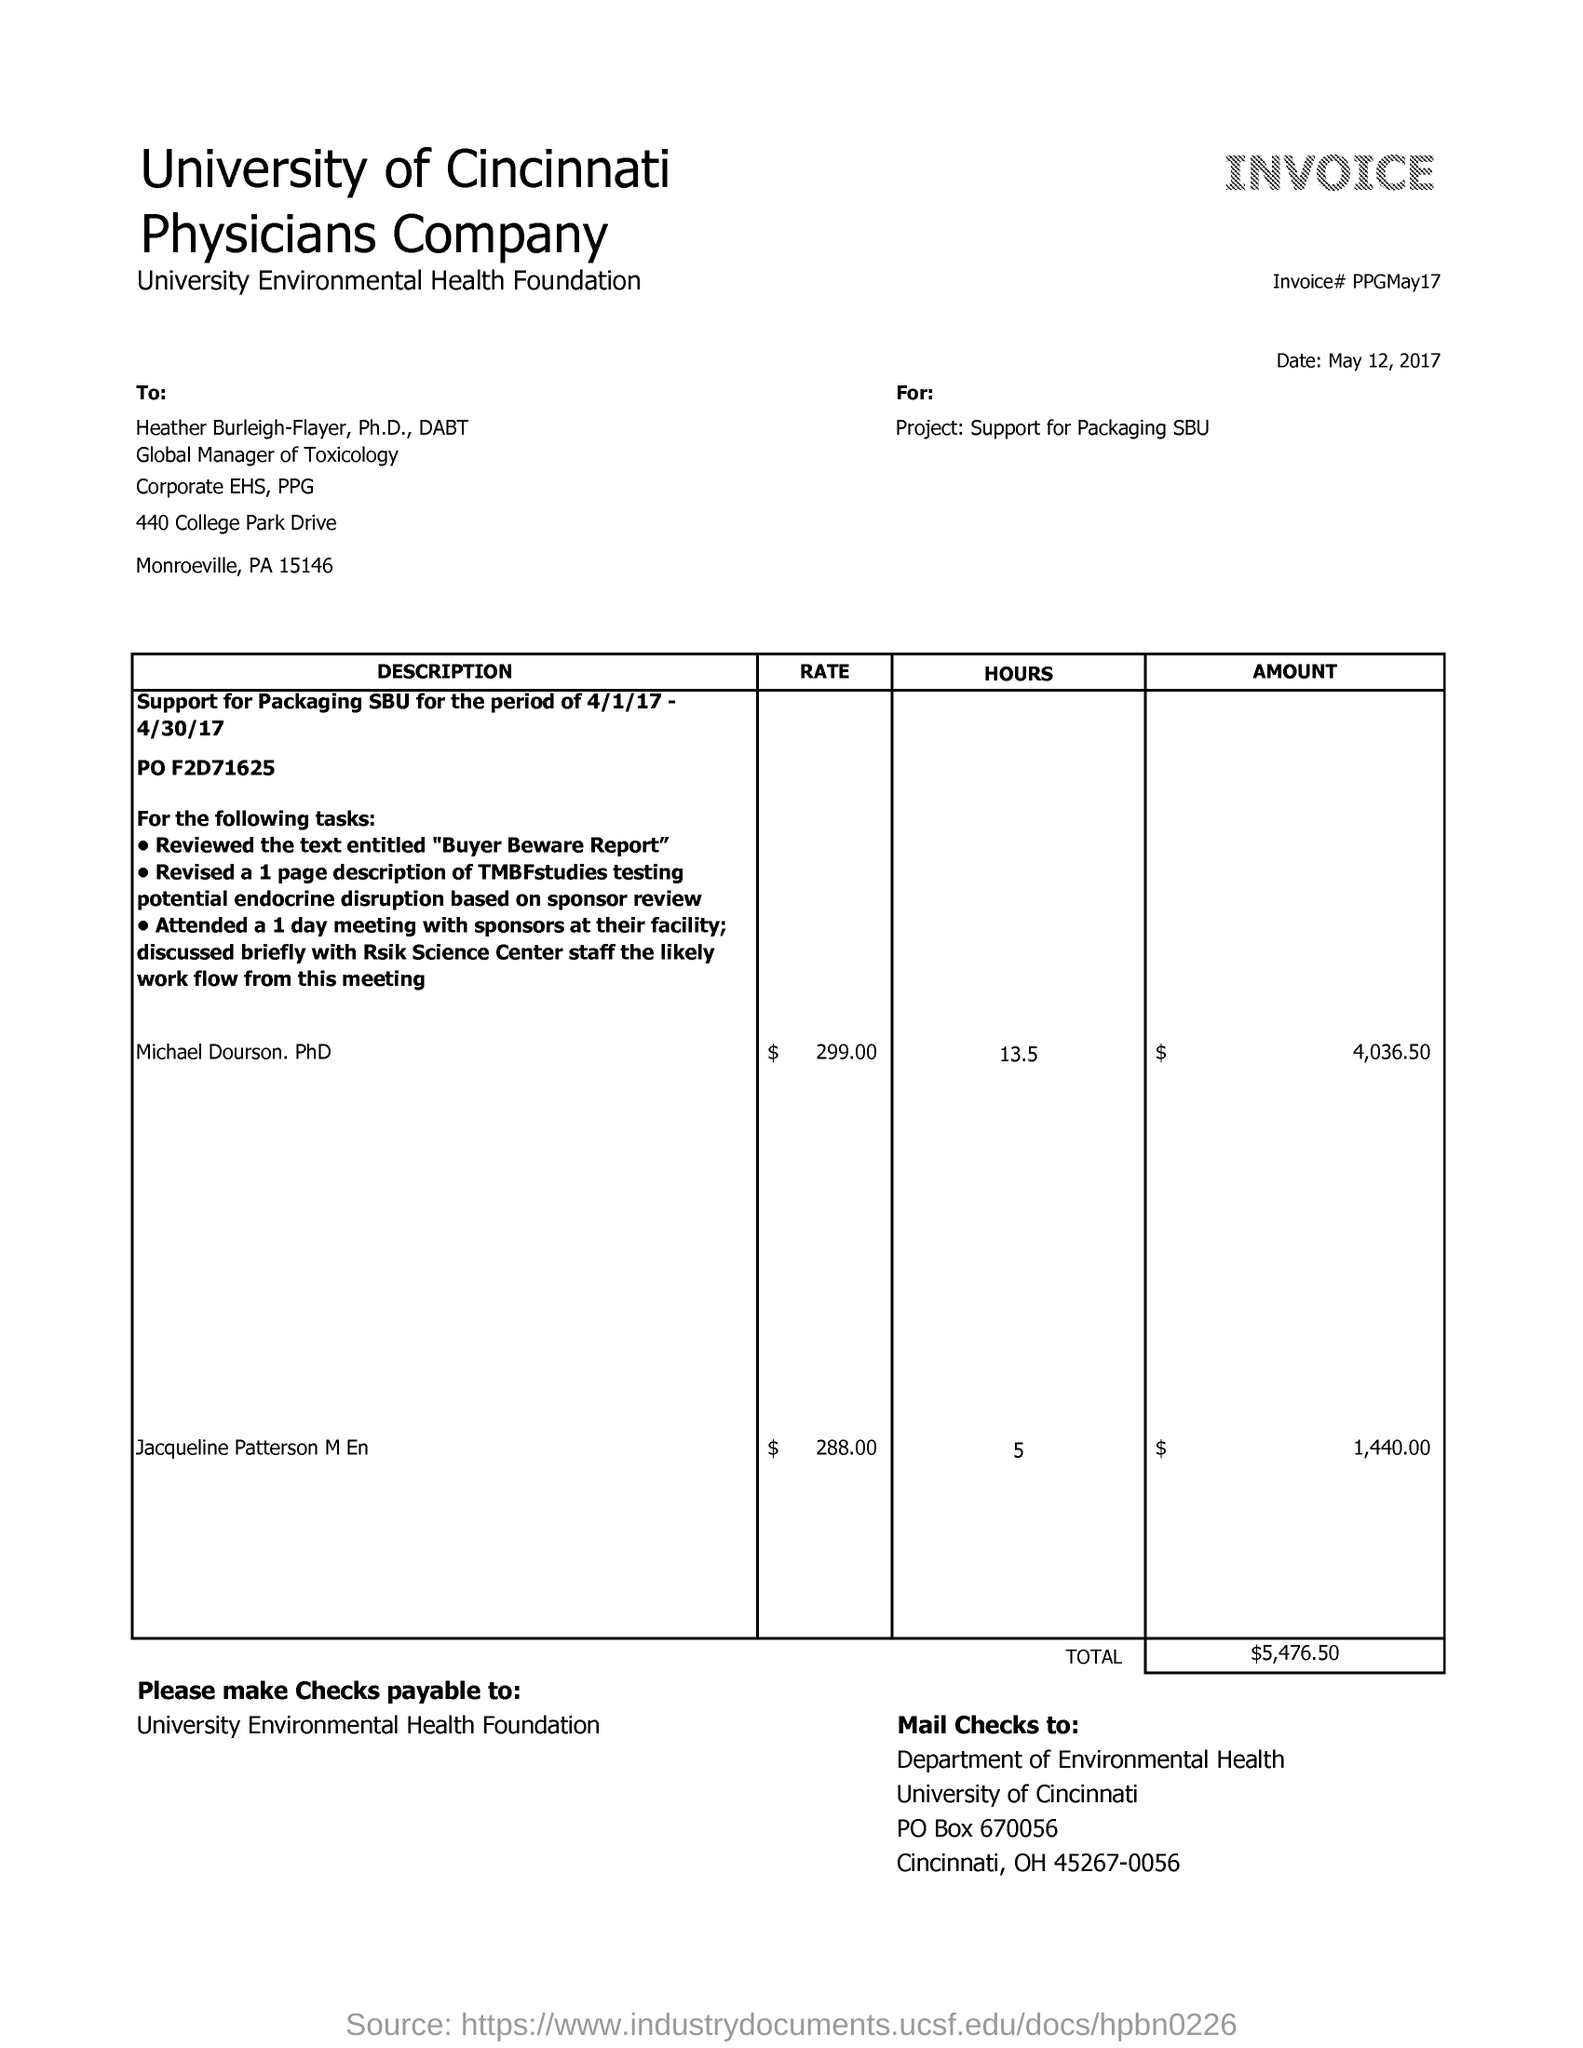Outline some significant characteristics in this image. The payment of checks will be done to the University Environmental Health Foundation. The date mentioned in the given invoice is May 12, 2017. The University Environmental Health Foundation is the name of the foundation. The University of Cincinnati is the name of the university. The total amount in the given invoice is $5,476.50. 